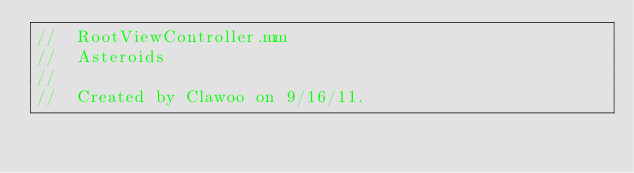<code> <loc_0><loc_0><loc_500><loc_500><_ObjectiveC_>//  RootViewController.mm
//  Asteroids
//
//  Created by Clawoo on 9/16/11.</code> 